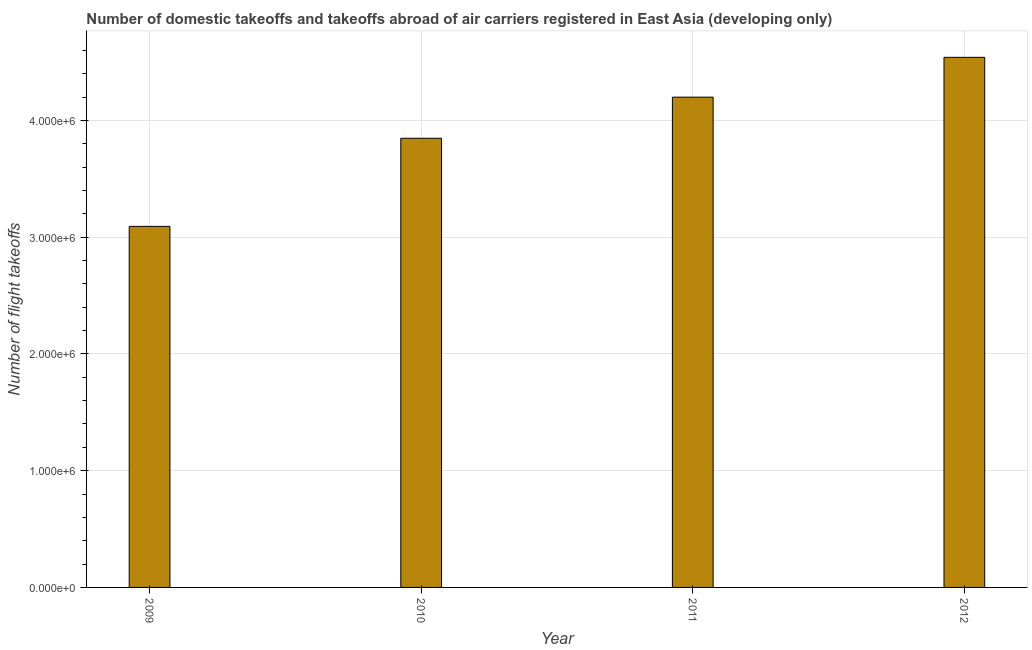Does the graph contain any zero values?
Your answer should be compact. No. What is the title of the graph?
Provide a succinct answer. Number of domestic takeoffs and takeoffs abroad of air carriers registered in East Asia (developing only). What is the label or title of the X-axis?
Offer a very short reply. Year. What is the label or title of the Y-axis?
Your answer should be compact. Number of flight takeoffs. What is the number of flight takeoffs in 2010?
Keep it short and to the point. 3.85e+06. Across all years, what is the maximum number of flight takeoffs?
Make the answer very short. 4.54e+06. Across all years, what is the minimum number of flight takeoffs?
Give a very brief answer. 3.09e+06. In which year was the number of flight takeoffs minimum?
Keep it short and to the point. 2009. What is the sum of the number of flight takeoffs?
Ensure brevity in your answer.  1.57e+07. What is the difference between the number of flight takeoffs in 2009 and 2010?
Provide a short and direct response. -7.55e+05. What is the average number of flight takeoffs per year?
Your response must be concise. 3.92e+06. What is the median number of flight takeoffs?
Your response must be concise. 4.02e+06. Do a majority of the years between 2011 and 2012 (inclusive) have number of flight takeoffs greater than 3600000 ?
Make the answer very short. Yes. What is the ratio of the number of flight takeoffs in 2011 to that in 2012?
Provide a short and direct response. 0.93. Is the number of flight takeoffs in 2011 less than that in 2012?
Your answer should be compact. Yes. Is the difference between the number of flight takeoffs in 2010 and 2011 greater than the difference between any two years?
Your response must be concise. No. What is the difference between the highest and the second highest number of flight takeoffs?
Provide a short and direct response. 3.41e+05. Is the sum of the number of flight takeoffs in 2010 and 2012 greater than the maximum number of flight takeoffs across all years?
Make the answer very short. Yes. What is the difference between the highest and the lowest number of flight takeoffs?
Provide a succinct answer. 1.45e+06. Are all the bars in the graph horizontal?
Offer a terse response. No. How many years are there in the graph?
Your answer should be very brief. 4. What is the Number of flight takeoffs in 2009?
Offer a terse response. 3.09e+06. What is the Number of flight takeoffs of 2010?
Your answer should be very brief. 3.85e+06. What is the Number of flight takeoffs in 2011?
Provide a succinct answer. 4.20e+06. What is the Number of flight takeoffs of 2012?
Provide a succinct answer. 4.54e+06. What is the difference between the Number of flight takeoffs in 2009 and 2010?
Give a very brief answer. -7.55e+05. What is the difference between the Number of flight takeoffs in 2009 and 2011?
Make the answer very short. -1.11e+06. What is the difference between the Number of flight takeoffs in 2009 and 2012?
Offer a very short reply. -1.45e+06. What is the difference between the Number of flight takeoffs in 2010 and 2011?
Your answer should be very brief. -3.52e+05. What is the difference between the Number of flight takeoffs in 2010 and 2012?
Your answer should be very brief. -6.93e+05. What is the difference between the Number of flight takeoffs in 2011 and 2012?
Your answer should be compact. -3.41e+05. What is the ratio of the Number of flight takeoffs in 2009 to that in 2010?
Give a very brief answer. 0.8. What is the ratio of the Number of flight takeoffs in 2009 to that in 2011?
Your response must be concise. 0.74. What is the ratio of the Number of flight takeoffs in 2009 to that in 2012?
Your answer should be very brief. 0.68. What is the ratio of the Number of flight takeoffs in 2010 to that in 2011?
Keep it short and to the point. 0.92. What is the ratio of the Number of flight takeoffs in 2010 to that in 2012?
Your response must be concise. 0.85. What is the ratio of the Number of flight takeoffs in 2011 to that in 2012?
Offer a terse response. 0.93. 